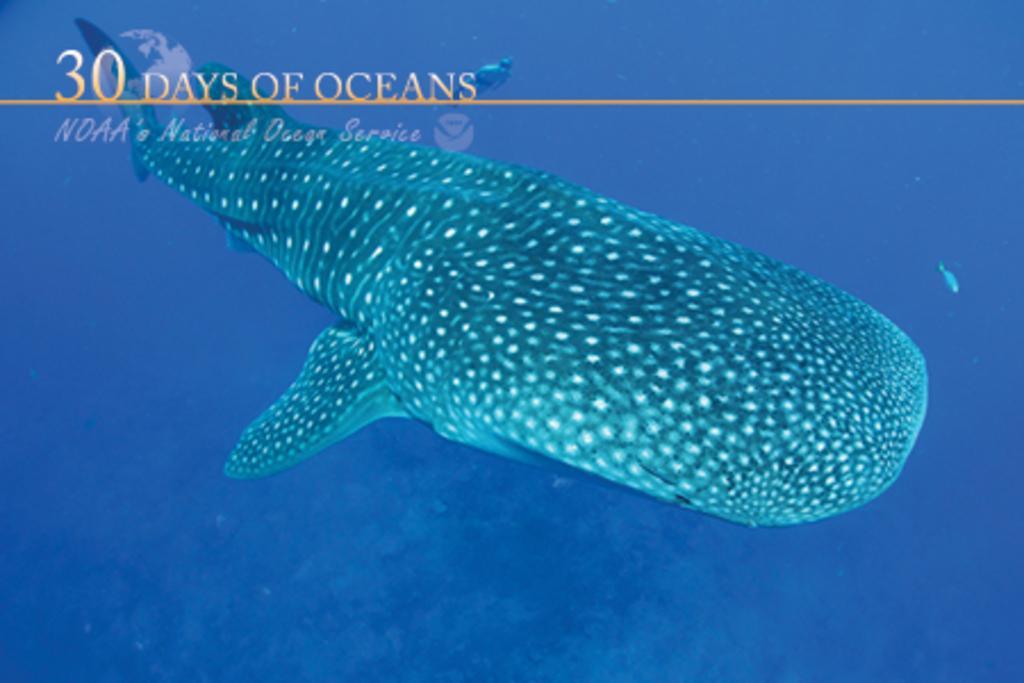Can you describe this image briefly? It is an animated image in which we can see there is a fish in the water. On the left side top there is some text. 